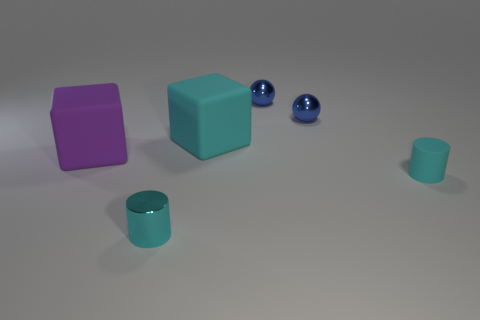The big cube behind the large matte block to the left of the small metal cylinder is made of what material?
Your answer should be very brief. Rubber. Do the big object that is behind the purple matte thing and the matte cylinder have the same color?
Ensure brevity in your answer.  Yes. How many other rubber things are the same shape as the large cyan rubber thing?
Your response must be concise. 1. What size is the purple object that is made of the same material as the cyan block?
Keep it short and to the point. Large. Is there a large purple rubber block behind the small cyan thing that is in front of the cyan matte cylinder that is in front of the cyan cube?
Your response must be concise. Yes. There is a rubber block to the left of the shiny cylinder; does it have the same size as the cyan rubber block?
Your answer should be compact. Yes. How many gray metallic cylinders have the same size as the cyan shiny thing?
Your answer should be very brief. 0. There is a block that is the same color as the matte cylinder; what is its size?
Your response must be concise. Large. Do the tiny matte cylinder and the metal cylinder have the same color?
Provide a short and direct response. Yes. The purple thing is what shape?
Offer a terse response. Cube. 